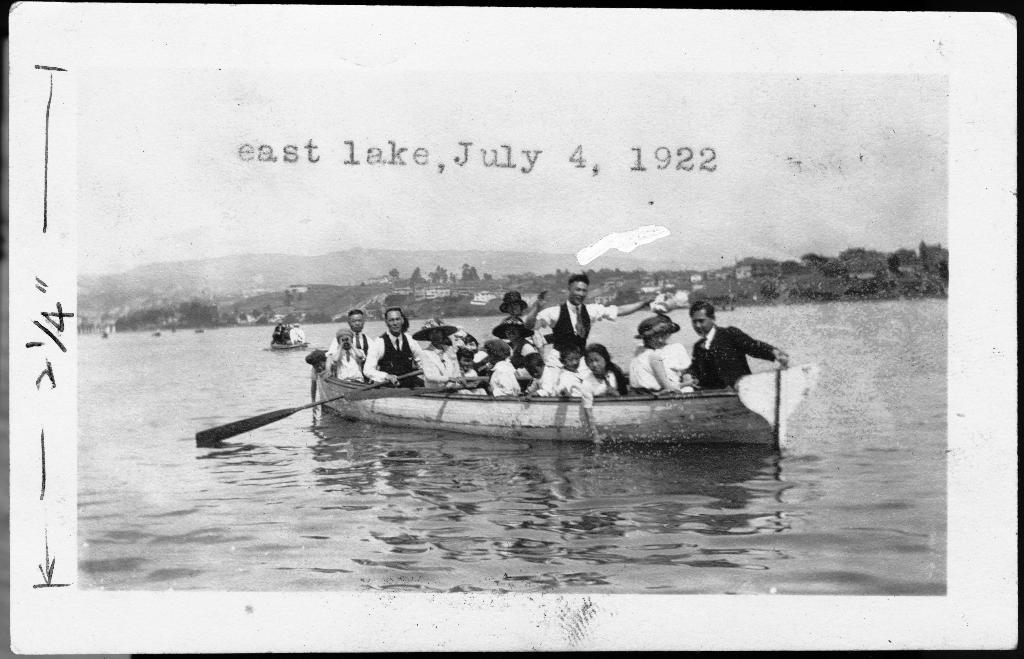What are the people in the image doing? The people in the image are sailing in boats. What type of terrain can be seen in the image? There is ground, water, and mountains visible in the image. What type of structures are present in the image? There are buildings and trees visible in the image. What part of the natural environment is visible in the image? The sky is visible in the image. Is there any text present in the image? Yes, there is some text present in the image. What type of calendar is hanging on the trees in the image? There is no calendar present in the image; it features people sailing in boats, a landscape with ground, water, mountains, buildings, trees, and the sky, and some text. How many cooks are visible in the image? There are no cooks present in the image. 